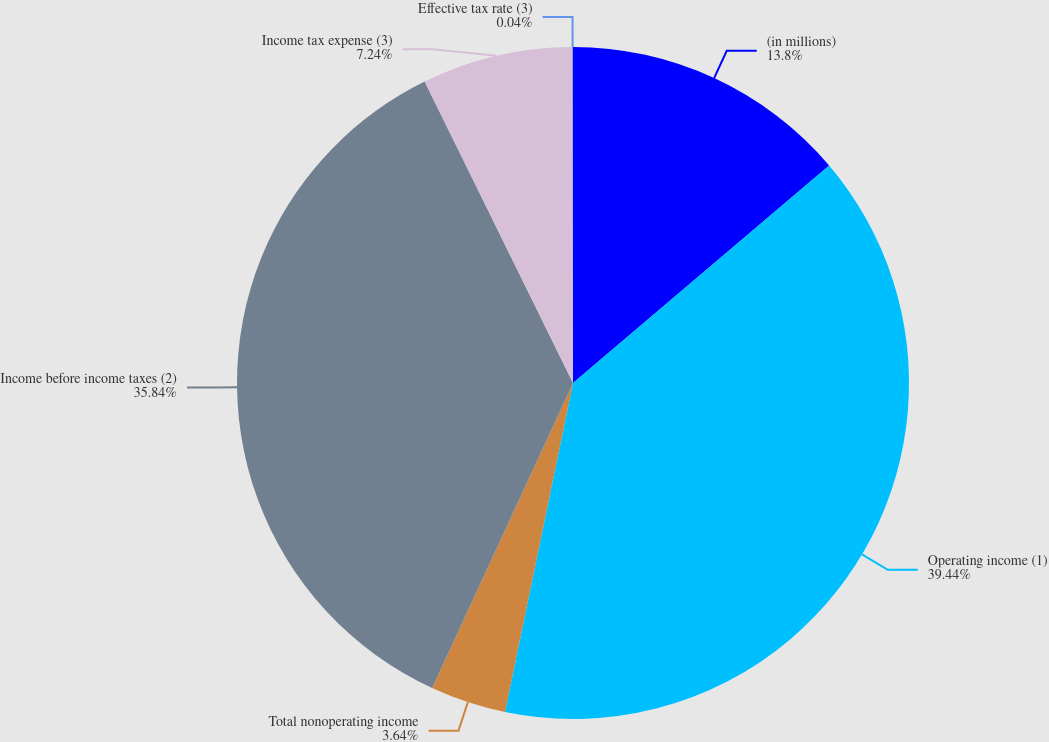<chart> <loc_0><loc_0><loc_500><loc_500><pie_chart><fcel>(in millions)<fcel>Operating income (1)<fcel>Total nonoperating income<fcel>Income before income taxes (2)<fcel>Income tax expense (3)<fcel>Effective tax rate (3)<nl><fcel>13.8%<fcel>39.45%<fcel>3.64%<fcel>35.84%<fcel>7.24%<fcel>0.04%<nl></chart> 